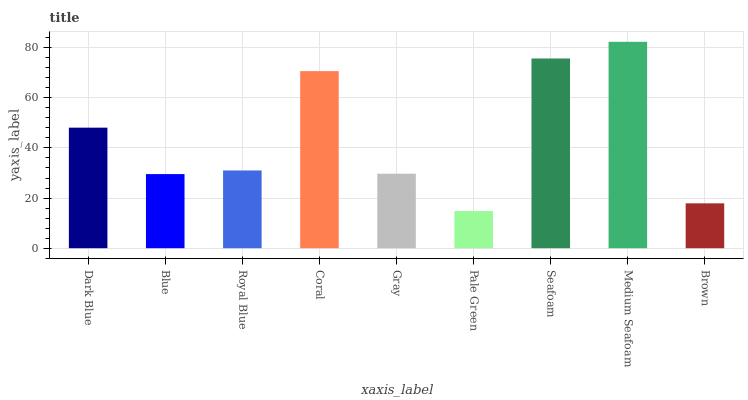Is Pale Green the minimum?
Answer yes or no. Yes. Is Medium Seafoam the maximum?
Answer yes or no. Yes. Is Blue the minimum?
Answer yes or no. No. Is Blue the maximum?
Answer yes or no. No. Is Dark Blue greater than Blue?
Answer yes or no. Yes. Is Blue less than Dark Blue?
Answer yes or no. Yes. Is Blue greater than Dark Blue?
Answer yes or no. No. Is Dark Blue less than Blue?
Answer yes or no. No. Is Royal Blue the high median?
Answer yes or no. Yes. Is Royal Blue the low median?
Answer yes or no. Yes. Is Gray the high median?
Answer yes or no. No. Is Gray the low median?
Answer yes or no. No. 